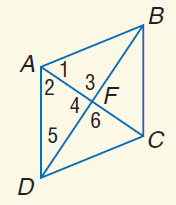Answer the mathemtical geometry problem and directly provide the correct option letter.
Question: Use rhombus A B C D with m \angle 1 = 2 x + 20, m \angle 2 = 5 x - 4, A C = 15, and m \angle 3 = y^ { 2 } + 26. Find x.
Choices: A: 2 B: 4 C: 6 D: 8 D 